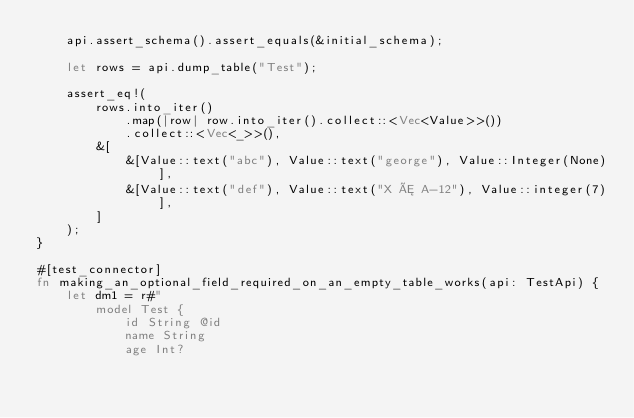<code> <loc_0><loc_0><loc_500><loc_500><_Rust_>    api.assert_schema().assert_equals(&initial_schema);

    let rows = api.dump_table("Test");

    assert_eq!(
        rows.into_iter()
            .map(|row| row.into_iter().collect::<Vec<Value>>())
            .collect::<Vec<_>>(),
        &[
            &[Value::text("abc"), Value::text("george"), Value::Integer(None)],
            &[Value::text("def"), Value::text("X Æ A-12"), Value::integer(7)],
        ]
    );
}

#[test_connector]
fn making_an_optional_field_required_on_an_empty_table_works(api: TestApi) {
    let dm1 = r#"
        model Test {
            id String @id
            name String
            age Int?</code> 